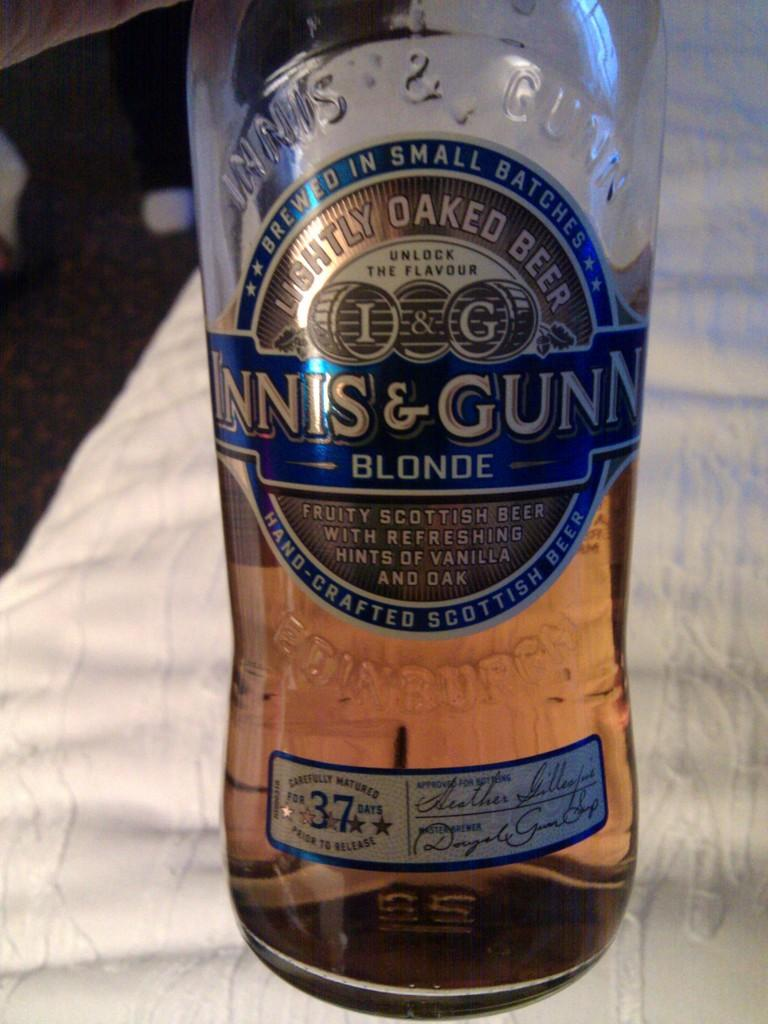<image>
Relay a brief, clear account of the picture shown. A half empty bottle of beer from Scotland. 